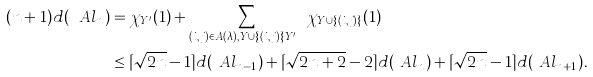Convert formula to latex. <formula><loc_0><loc_0><loc_500><loc_500>( n + 1 ) d ( \ A l _ { n } ) & = \chi _ { Y ^ { \prime } } ( 1 ) + \sum _ { ( i , j ) \in A ( \lambda ) , Y \cup \{ ( i , j ) \} \neq Y ^ { \prime } } \chi _ { Y \cup \{ ( i , j ) \} } ( 1 ) \\ & \leq \lceil \sqrt { 2 n } - 1 \rceil d ( \ A l _ { n - 1 } ) + \lceil \sqrt { 2 n + 2 } - 2 \rceil d ( \ A l _ { n } ) + \lceil \sqrt { 2 n } - 1 \rceil d ( \ A l _ { n + 1 } ) .</formula> 